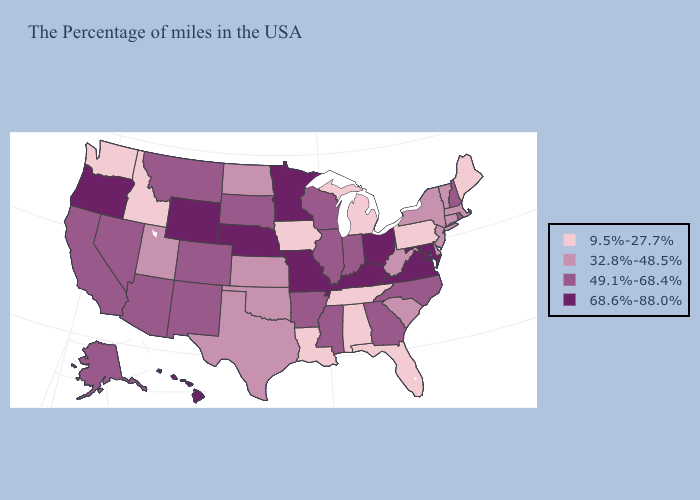Name the states that have a value in the range 32.8%-48.5%?
Be succinct. Massachusetts, Vermont, Connecticut, New York, New Jersey, Delaware, South Carolina, West Virginia, Kansas, Oklahoma, Texas, North Dakota, Utah. What is the value of Alabama?
Concise answer only. 9.5%-27.7%. Name the states that have a value in the range 49.1%-68.4%?
Concise answer only. Rhode Island, New Hampshire, North Carolina, Georgia, Indiana, Wisconsin, Illinois, Mississippi, Arkansas, South Dakota, Colorado, New Mexico, Montana, Arizona, Nevada, California, Alaska. Does Wyoming have a higher value than Nebraska?
Write a very short answer. No. Among the states that border South Dakota , does Iowa have the lowest value?
Keep it brief. Yes. Name the states that have a value in the range 49.1%-68.4%?
Short answer required. Rhode Island, New Hampshire, North Carolina, Georgia, Indiana, Wisconsin, Illinois, Mississippi, Arkansas, South Dakota, Colorado, New Mexico, Montana, Arizona, Nevada, California, Alaska. Among the states that border Georgia , which have the lowest value?
Be succinct. Florida, Alabama, Tennessee. How many symbols are there in the legend?
Answer briefly. 4. What is the highest value in the USA?
Answer briefly. 68.6%-88.0%. What is the value of Indiana?
Keep it brief. 49.1%-68.4%. Which states have the highest value in the USA?
Short answer required. Maryland, Virginia, Ohio, Kentucky, Missouri, Minnesota, Nebraska, Wyoming, Oregon, Hawaii. What is the lowest value in the West?
Write a very short answer. 9.5%-27.7%. Among the states that border Illinois , which have the highest value?
Short answer required. Kentucky, Missouri. What is the highest value in the USA?
Give a very brief answer. 68.6%-88.0%. What is the value of New Hampshire?
Keep it brief. 49.1%-68.4%. 